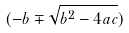Convert formula to latex. <formula><loc_0><loc_0><loc_500><loc_500>( - b \mp \sqrt { b ^ { 2 } - 4 a c } )</formula> 